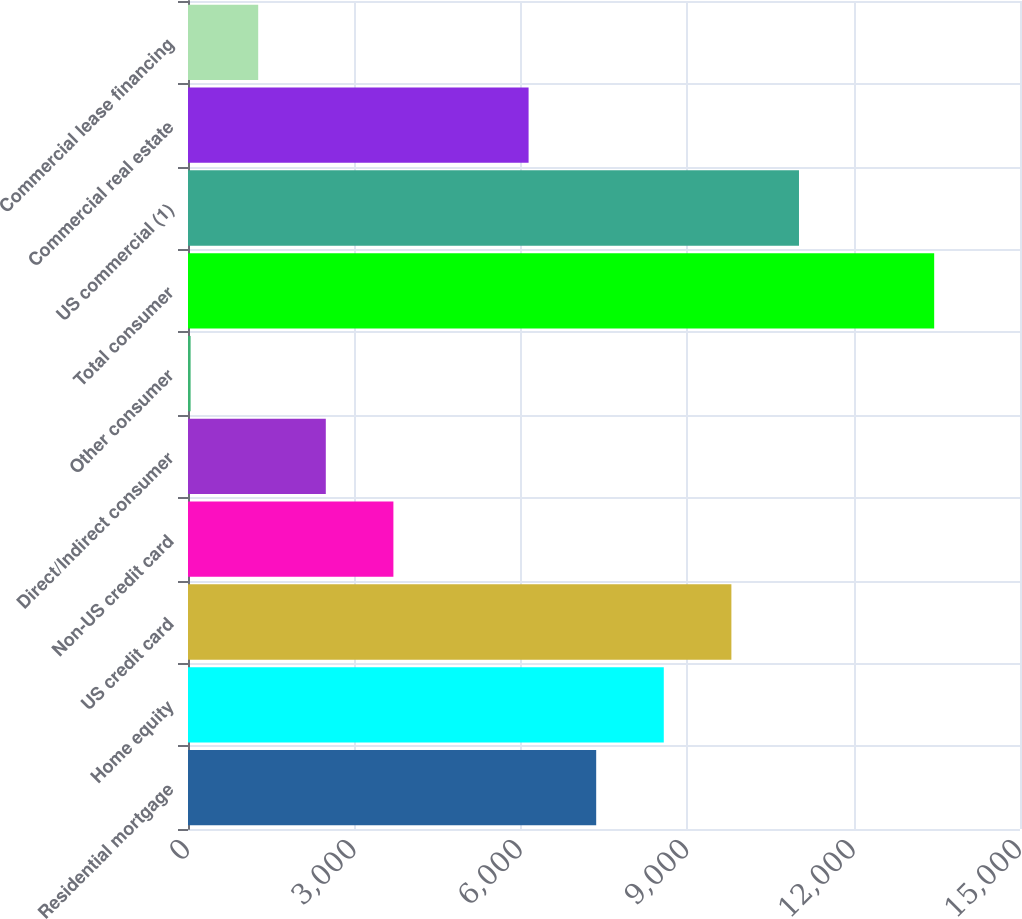<chart> <loc_0><loc_0><loc_500><loc_500><bar_chart><fcel>Residential mortgage<fcel>Home equity<fcel>US credit card<fcel>Non-US credit card<fcel>Direct/Indirect consumer<fcel>Other consumer<fcel>Total consumer<fcel>US commercial (1)<fcel>Commercial real estate<fcel>Commercial lease financing<nl><fcel>7359.2<fcel>8577.9<fcel>9796.6<fcel>3703.1<fcel>2484.4<fcel>47<fcel>13452.7<fcel>11015.3<fcel>6140.5<fcel>1265.7<nl></chart> 